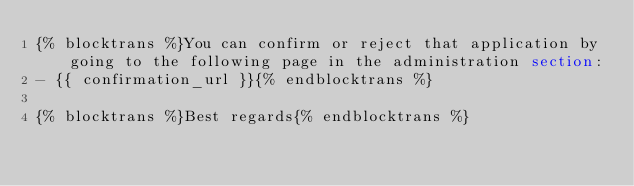<code> <loc_0><loc_0><loc_500><loc_500><_HTML_>{% blocktrans %}You can confirm or reject that application by going to the following page in the administration section:
- {{ confirmation_url }}{% endblocktrans %}

{% blocktrans %}Best regards{% endblocktrans %}
</code> 